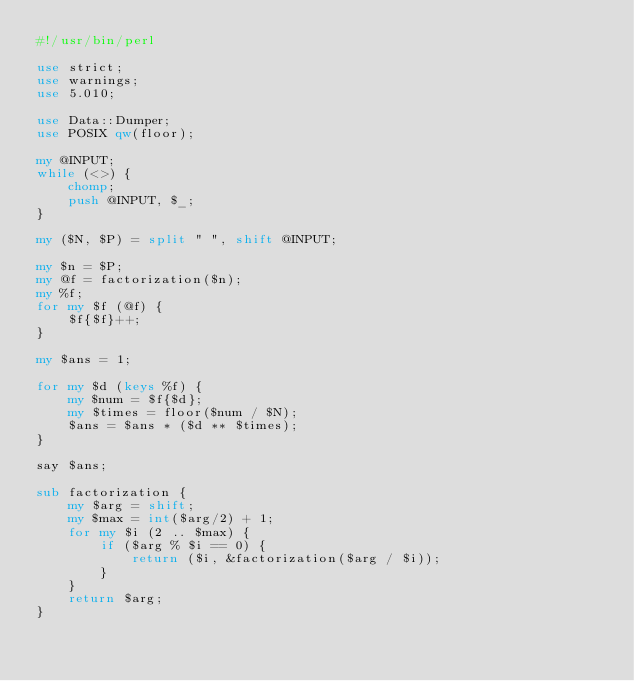Convert code to text. <code><loc_0><loc_0><loc_500><loc_500><_Perl_>#!/usr/bin/perl

use strict;
use warnings;
use 5.010;

use Data::Dumper;
use POSIX qw(floor);

my @INPUT;
while (<>) {
    chomp;
    push @INPUT, $_;
}

my ($N, $P) = split " ", shift @INPUT;

my $n = $P;
my @f = factorization($n);
my %f;
for my $f (@f) {
    $f{$f}++;
}

my $ans = 1;

for my $d (keys %f) {
    my $num = $f{$d};
    my $times = floor($num / $N);
    $ans = $ans * ($d ** $times);
}

say $ans;

sub factorization {
    my $arg = shift;
    my $max = int($arg/2) + 1;
    for my $i (2 .. $max) {
        if ($arg % $i == 0) {
            return ($i, &factorization($arg / $i));
        }
    }
    return $arg;
}
</code> 